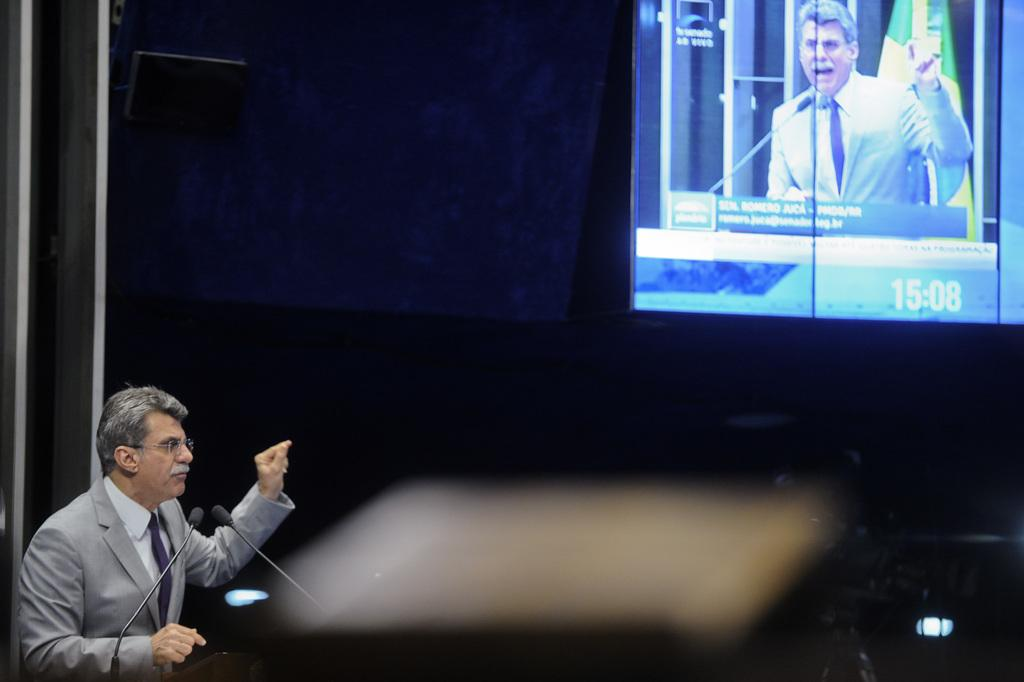<image>
Relay a brief, clear account of the picture shown. A man in a grey suit gives a lecture at 15:08 